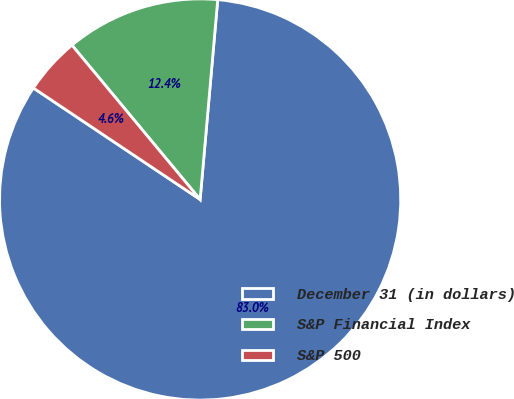Convert chart. <chart><loc_0><loc_0><loc_500><loc_500><pie_chart><fcel>December 31 (in dollars)<fcel>S&P Financial Index<fcel>S&P 500<nl><fcel>82.98%<fcel>12.43%<fcel>4.59%<nl></chart> 